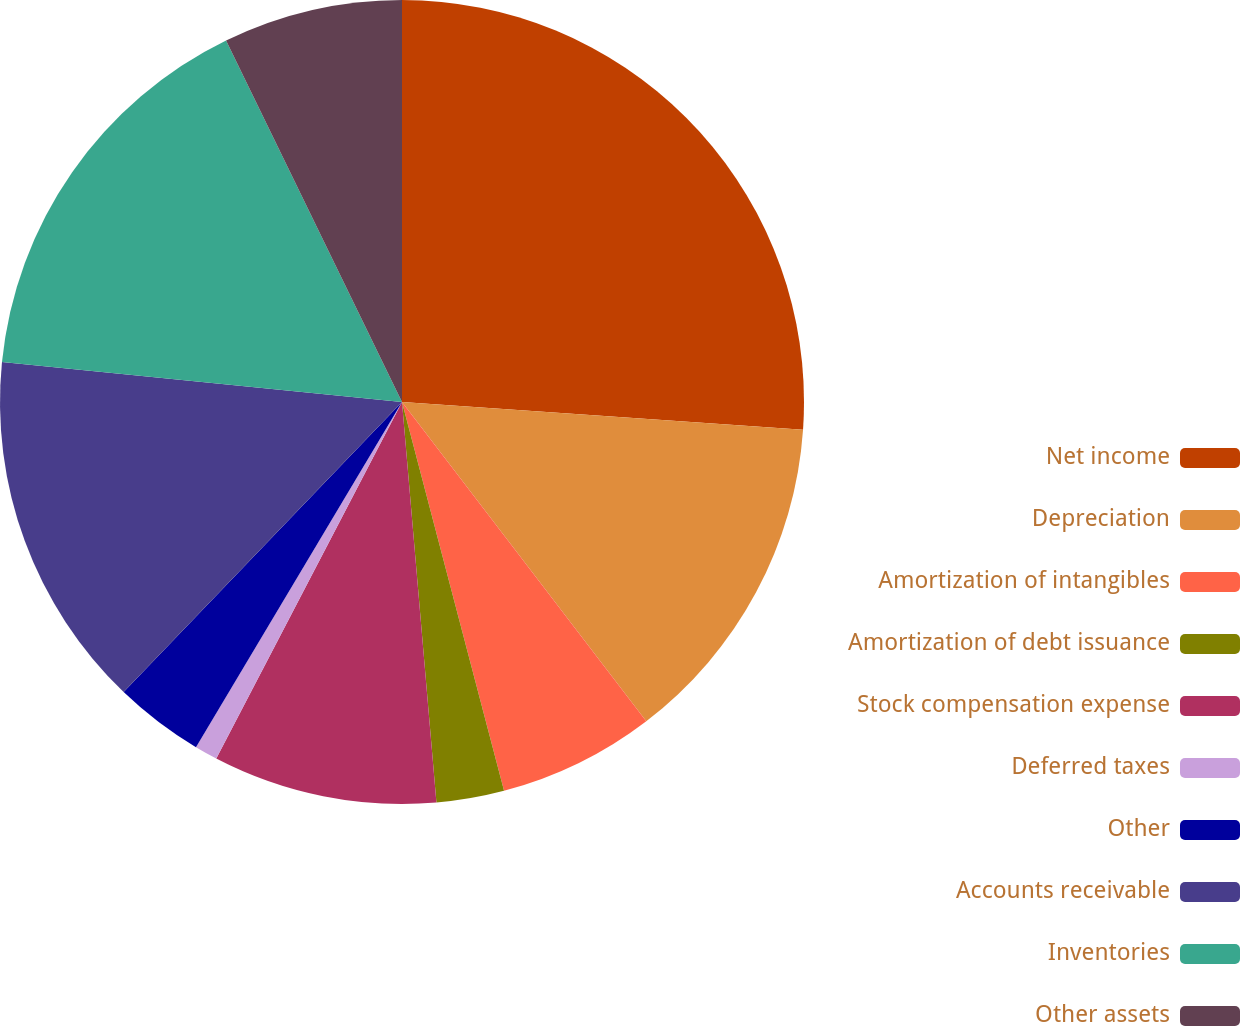Convert chart. <chart><loc_0><loc_0><loc_500><loc_500><pie_chart><fcel>Net income<fcel>Depreciation<fcel>Amortization of intangibles<fcel>Amortization of debt issuance<fcel>Stock compensation expense<fcel>Deferred taxes<fcel>Other<fcel>Accounts receivable<fcel>Inventories<fcel>Other assets<nl><fcel>26.1%<fcel>13.51%<fcel>6.31%<fcel>2.72%<fcel>9.01%<fcel>0.92%<fcel>3.61%<fcel>14.41%<fcel>16.21%<fcel>7.21%<nl></chart> 